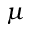Convert formula to latex. <formula><loc_0><loc_0><loc_500><loc_500>\mu</formula> 